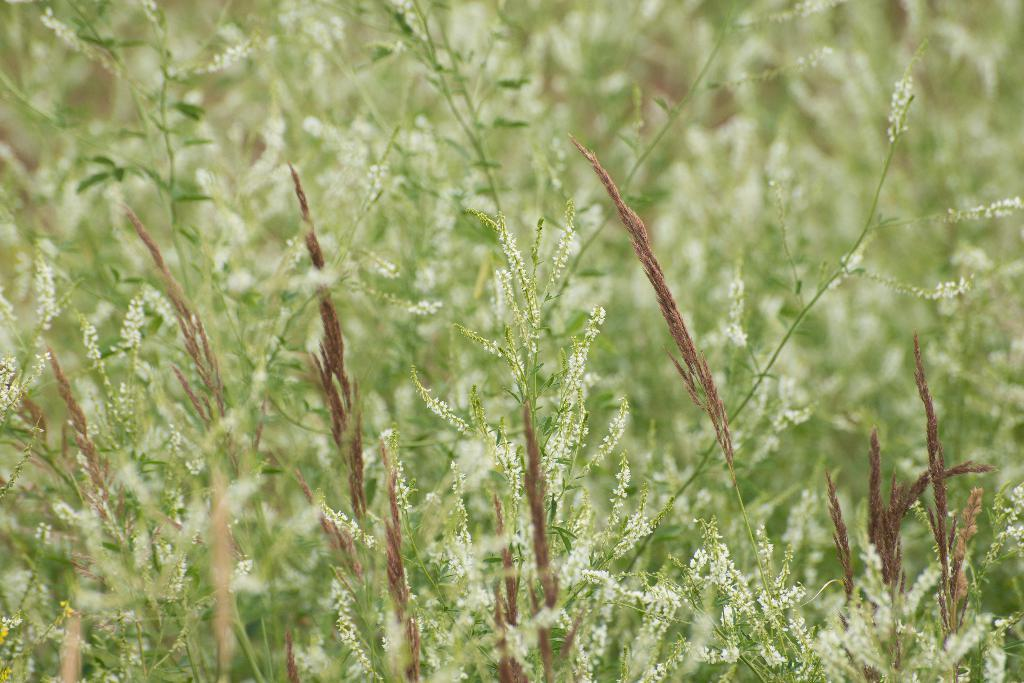What type of living organisms can be seen in the image? Plants can be seen in the image. What type of leg is visible in the image? There is no leg visible in the image; it only features plants. 